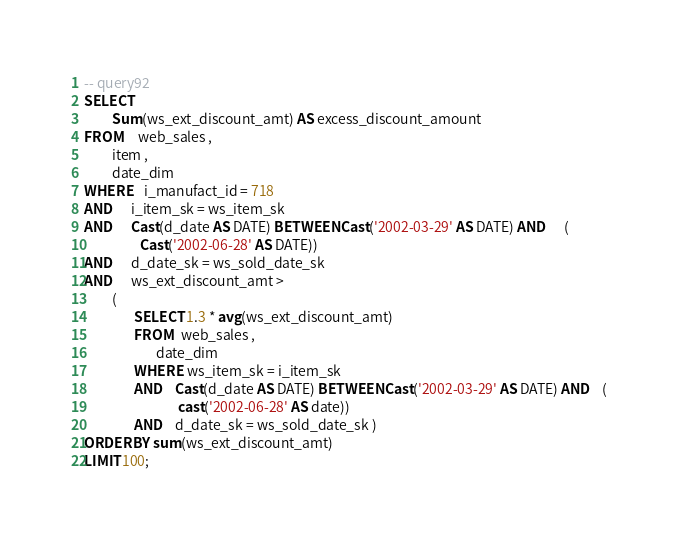<code> <loc_0><loc_0><loc_500><loc_500><_SQL_>-- query92
SELECT 
         Sum(ws_ext_discount_amt) AS excess_discount_amount
FROM     web_sales , 
         item , 
         date_dim 
WHERE    i_manufact_id = 718 
AND      i_item_sk = ws_item_sk 
AND      Cast(d_date AS DATE) BETWEEN Cast('2002-03-29' AS DATE) AND      ( 
                  Cast('2002-06-28' AS DATE)) 
AND      d_date_sk = ws_sold_date_sk 
AND      ws_ext_discount_amt > 
         ( 
                SELECT 1.3 * avg(ws_ext_discount_amt) 
                FROM   web_sales , 
                       date_dim 
                WHERE  ws_item_sk = i_item_sk 
                AND    Cast(d_date AS DATE) BETWEEN Cast('2002-03-29' AS DATE) AND    ( 
                              cast('2002-06-28' AS date)) 
                AND    d_date_sk = ws_sold_date_sk ) 
ORDER BY sum(ws_ext_discount_amt) 
LIMIT 100; 

</code> 